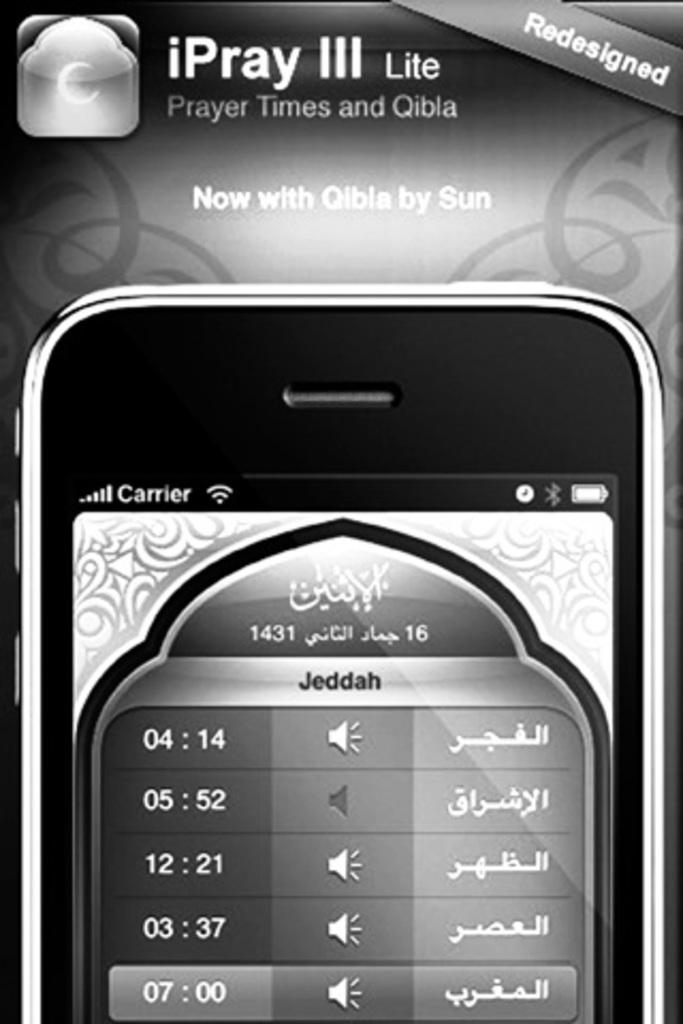Provide a one-sentence caption for the provided image. A picture of a cell phone that has a redesigned message on the front. 